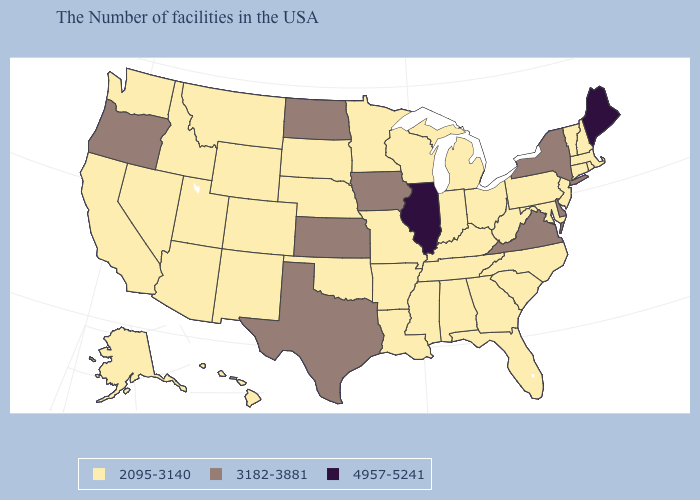Name the states that have a value in the range 3182-3881?
Give a very brief answer. New York, Delaware, Virginia, Iowa, Kansas, Texas, North Dakota, Oregon. Name the states that have a value in the range 2095-3140?
Give a very brief answer. Massachusetts, Rhode Island, New Hampshire, Vermont, Connecticut, New Jersey, Maryland, Pennsylvania, North Carolina, South Carolina, West Virginia, Ohio, Florida, Georgia, Michigan, Kentucky, Indiana, Alabama, Tennessee, Wisconsin, Mississippi, Louisiana, Missouri, Arkansas, Minnesota, Nebraska, Oklahoma, South Dakota, Wyoming, Colorado, New Mexico, Utah, Montana, Arizona, Idaho, Nevada, California, Washington, Alaska, Hawaii. How many symbols are there in the legend?
Short answer required. 3. Does Colorado have the highest value in the West?
Quick response, please. No. Name the states that have a value in the range 2095-3140?
Short answer required. Massachusetts, Rhode Island, New Hampshire, Vermont, Connecticut, New Jersey, Maryland, Pennsylvania, North Carolina, South Carolina, West Virginia, Ohio, Florida, Georgia, Michigan, Kentucky, Indiana, Alabama, Tennessee, Wisconsin, Mississippi, Louisiana, Missouri, Arkansas, Minnesota, Nebraska, Oklahoma, South Dakota, Wyoming, Colorado, New Mexico, Utah, Montana, Arizona, Idaho, Nevada, California, Washington, Alaska, Hawaii. What is the value of Kentucky?
Answer briefly. 2095-3140. Name the states that have a value in the range 3182-3881?
Write a very short answer. New York, Delaware, Virginia, Iowa, Kansas, Texas, North Dakota, Oregon. What is the highest value in the USA?
Give a very brief answer. 4957-5241. Name the states that have a value in the range 3182-3881?
Concise answer only. New York, Delaware, Virginia, Iowa, Kansas, Texas, North Dakota, Oregon. What is the highest value in the USA?
Answer briefly. 4957-5241. What is the highest value in the USA?
Concise answer only. 4957-5241. What is the value of Maine?
Write a very short answer. 4957-5241. Among the states that border Georgia , which have the highest value?
Keep it brief. North Carolina, South Carolina, Florida, Alabama, Tennessee. Does the first symbol in the legend represent the smallest category?
Short answer required. Yes. 